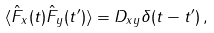<formula> <loc_0><loc_0><loc_500><loc_500>\langle \hat { F } _ { x } ( t ) \hat { F } _ { y } ( t ^ { \prime } ) \rangle = D _ { x y } \delta ( t - t ^ { \prime } ) \, ,</formula> 